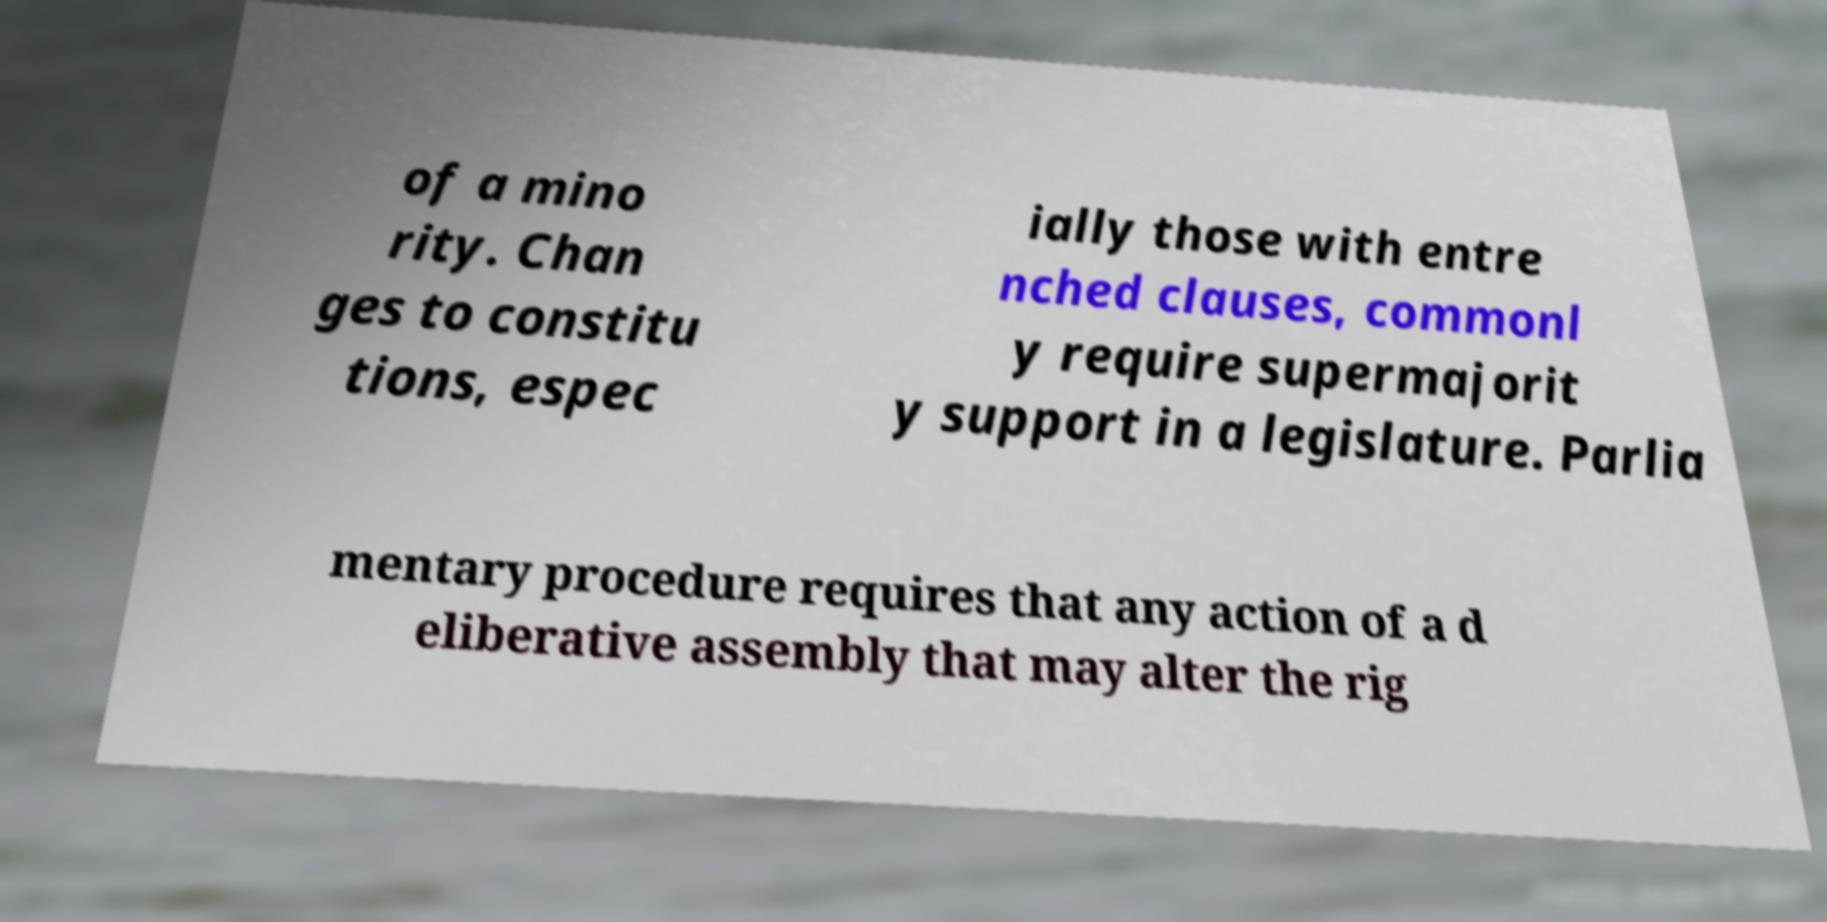I need the written content from this picture converted into text. Can you do that? of a mino rity. Chan ges to constitu tions, espec ially those with entre nched clauses, commonl y require supermajorit y support in a legislature. Parlia mentary procedure requires that any action of a d eliberative assembly that may alter the rig 